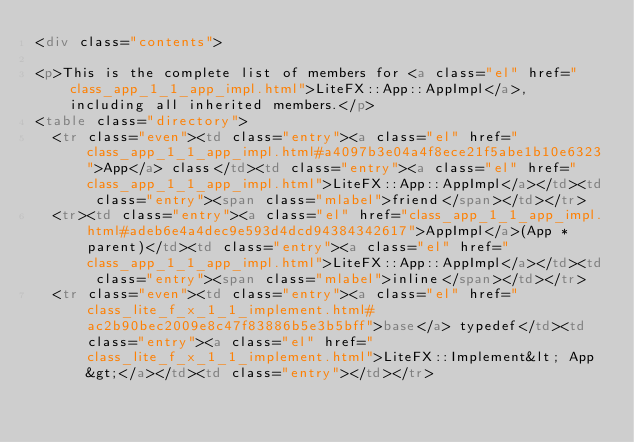<code> <loc_0><loc_0><loc_500><loc_500><_HTML_><div class="contents">

<p>This is the complete list of members for <a class="el" href="class_app_1_1_app_impl.html">LiteFX::App::AppImpl</a>, including all inherited members.</p>
<table class="directory">
  <tr class="even"><td class="entry"><a class="el" href="class_app_1_1_app_impl.html#a4097b3e04a4f8ece21f5abe1b10e6323">App</a> class</td><td class="entry"><a class="el" href="class_app_1_1_app_impl.html">LiteFX::App::AppImpl</a></td><td class="entry"><span class="mlabel">friend</span></td></tr>
  <tr><td class="entry"><a class="el" href="class_app_1_1_app_impl.html#adeb6e4a4dec9e593d4dcd94384342617">AppImpl</a>(App *parent)</td><td class="entry"><a class="el" href="class_app_1_1_app_impl.html">LiteFX::App::AppImpl</a></td><td class="entry"><span class="mlabel">inline</span></td></tr>
  <tr class="even"><td class="entry"><a class="el" href="class_lite_f_x_1_1_implement.html#ac2b90bec2009e8c47f83886b5e3b5bff">base</a> typedef</td><td class="entry"><a class="el" href="class_lite_f_x_1_1_implement.html">LiteFX::Implement&lt; App &gt;</a></td><td class="entry"></td></tr></code> 